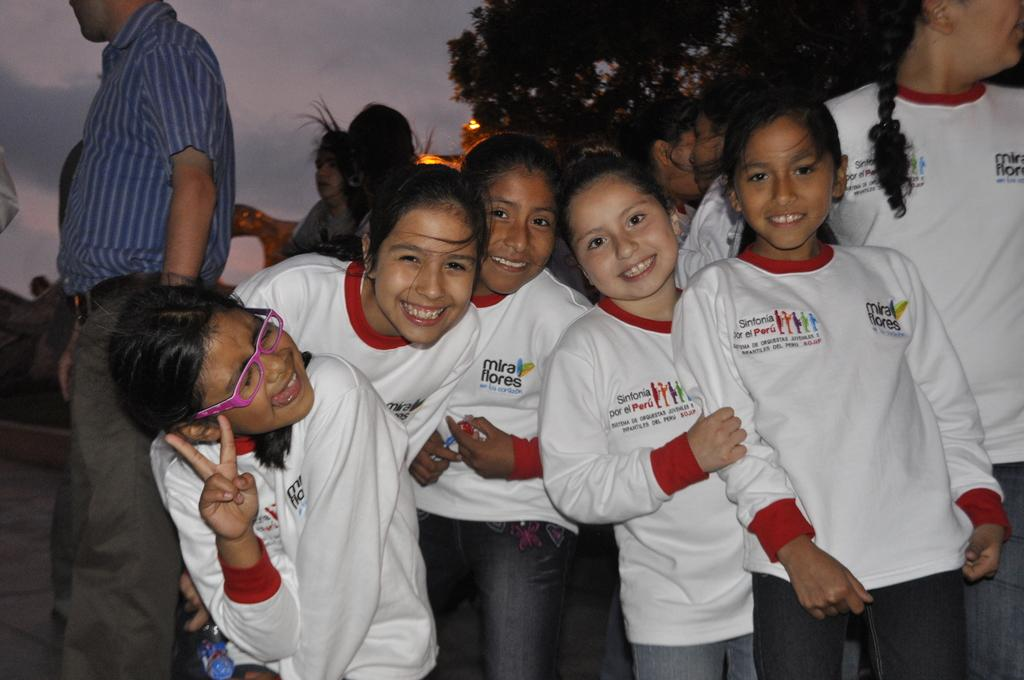What are the people in the image doing? The persons in the image are standing on the road. What can be seen in the background of the image? Sky and trees are visible in the background of the image. What is the condition of the sky in the image? Clouds are present in the sky, which suggests a partly cloudy day. What type of honey is being collected from the yard in the image? There is no yard or honey present in the image; it features persons standing on the road with a background of sky and trees. 